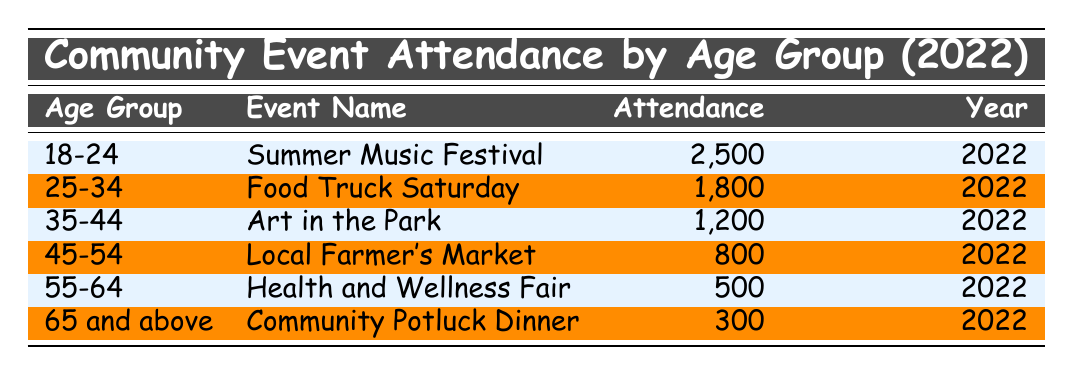What is the attendance for the "Summer Music Festival"? The table shows that the attendance for the "Summer Music Festival" in the age group 18-24 is 2,500.
Answer: 2500 Which age group has the lowest attendance? From the table, the "Community Potluck Dinner" under the age group "65 and above" has the lowest attendance of 300.
Answer: 65 and above What is the total attendance for all events combined? To find the total, I will sum the attendance from all age groups: 2500 + 1800 + 1200 + 800 + 500 + 300 = 6100.
Answer: 6100 Is the attendance for the "Health and Wellness Fair" greater than the attendance for the "Local Farmer's Market"? The attendance for the "Health and Wellness Fair" is 500, while for the "Local Farmer's Market" it is 800, so 500 is not greater than 800.
Answer: No What is the average attendance for the age group "35-44"? There is only one event listed for the age group "35-44", which is "Art in the Park" with an attendance of 1,200. Therefore, the average attendance is simply 1,200.
Answer: 1200 Which event had more attendees, "Food Truck Saturday" or "Art in the Park"? The attendance for "Food Truck Saturday" is 1,800, while the attendance for "Art in the Park" is 1,200. Since 1,800 is greater than 1,200, "Food Truck Saturday" had more attendees.
Answer: Food Truck Saturday How many attendees were there for age groups 45 and older? The age groups 45-54 and 65 and above have attendances of 800 and 300, respectively. Thus, the total for age groups 45 and older is 800 + 300 = 1,100.
Answer: 1100 True or False: More than 1,000 people attended the "Summer Music Festival." The attendance for the "Summer Music Festival" is 2,500, which is indeed more than 1,000.
Answer: True 